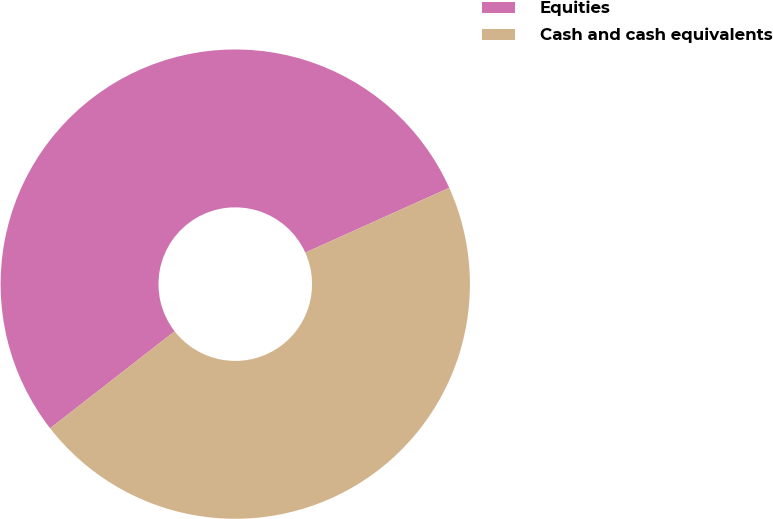<chart> <loc_0><loc_0><loc_500><loc_500><pie_chart><fcel>Equities<fcel>Cash and cash equivalents<nl><fcel>53.8%<fcel>46.2%<nl></chart> 